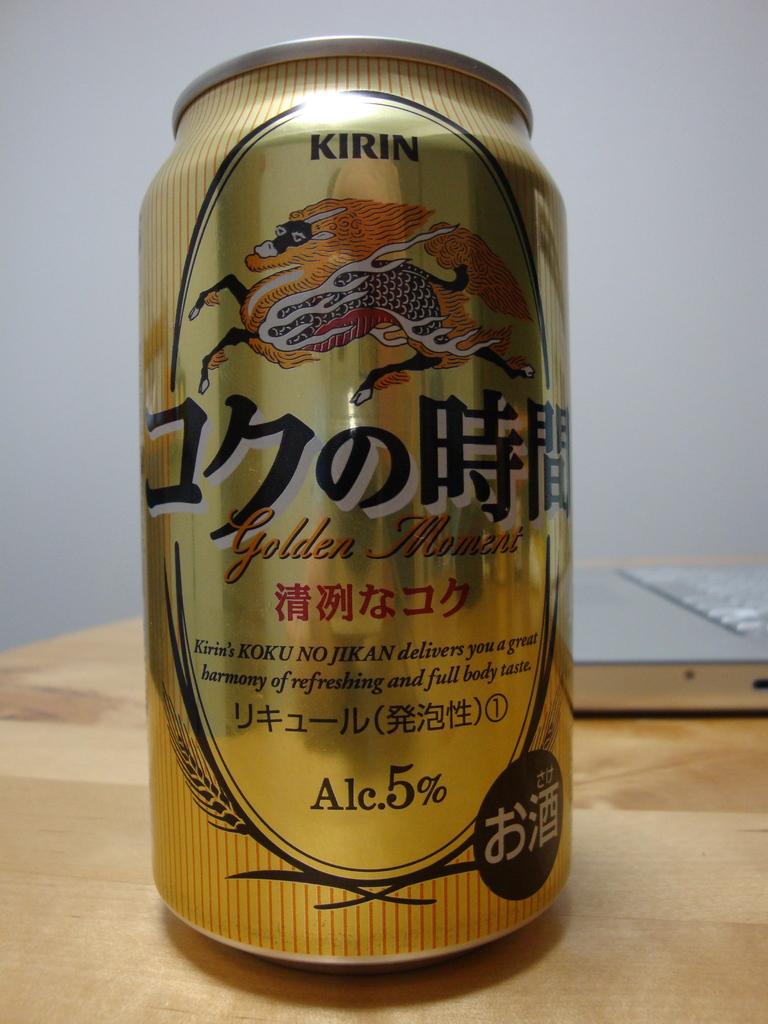What is the alcohol percentage in this drink?
Your answer should be compact. 5%. 